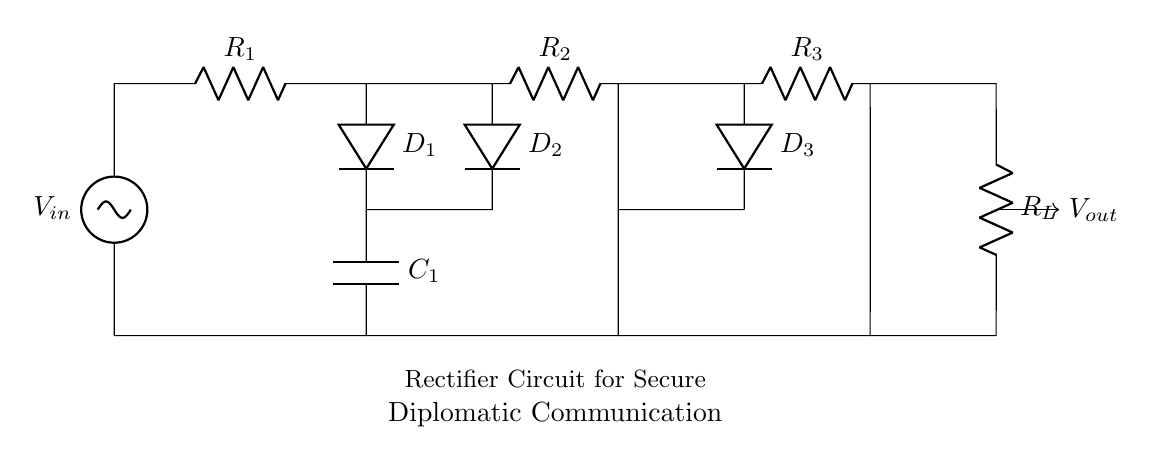What is the input voltage of the circuit? The input voltage is labeled as V_in, which indicates the source voltage provided to the circuit.
Answer: V_in How many diodes are present in the circuit? The circuit shows a total of three diodes, represented as D_1, D_2, and D_3.
Answer: 3 What components are used for current limiting in this circuit? The components used for current limiting are resistors, labeled as R_1, R_2, R_3, and R_L, which are located in series with the diodes.
Answer: Resistors What is the purpose of the capacitor in the circuit? The capacitor, labeled C_1, is used to smooth the output voltage by filtering the rectified signal, reducing ripple.
Answer: Smoothing output Which component directly prevents reverse current in this circuit? The diodes (D_1, D_2, D_3) prevent reverse current by allowing current to flow only in one direction.
Answer: Diodes What is the output voltage of the circuit in relation to the input voltage? The output voltage is connected to the point after the rectification process, generally indicating it is equal to or less than the input voltage after diode drops.
Answer: V_out How are the diodes connected in the circuit? The diodes are arranged in series and parallel configurations to facilitate full-wave rectification of the input voltage.
Answer: Series and parallel 